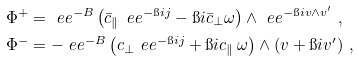<formula> <loc_0><loc_0><loc_500><loc_500>\Phi ^ { + } & = \ e e ^ { - B } \left ( \bar { c } _ { \| } \, \ e e ^ { - \i i j } - \i i \bar { c } _ { \bot } \omega \right ) \wedge \ e e ^ { - \i i v \wedge v ^ { \prime } } \ , \\ \Phi ^ { - } & = - \ e e ^ { - B } \left ( c _ { \bot } \ e e ^ { - \i i j } + \i i c _ { \| } \, \omega \right ) \wedge ( v + \i i v ^ { \prime } ) \ ,</formula> 